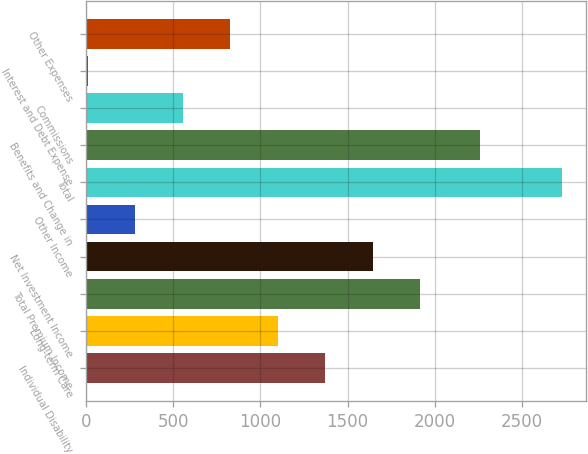<chart> <loc_0><loc_0><loc_500><loc_500><bar_chart><fcel>Individual Disability<fcel>Long-term Care<fcel>Total Premium Income<fcel>Net Investment Income<fcel>Other Income<fcel>Total<fcel>Benefits and Change in<fcel>Commissions<fcel>Interest and Debt Expense<fcel>Other Expenses<nl><fcel>1370.7<fcel>1098.9<fcel>1914.3<fcel>1642.5<fcel>283.5<fcel>2729.7<fcel>2259.2<fcel>555.3<fcel>11.7<fcel>827.1<nl></chart> 